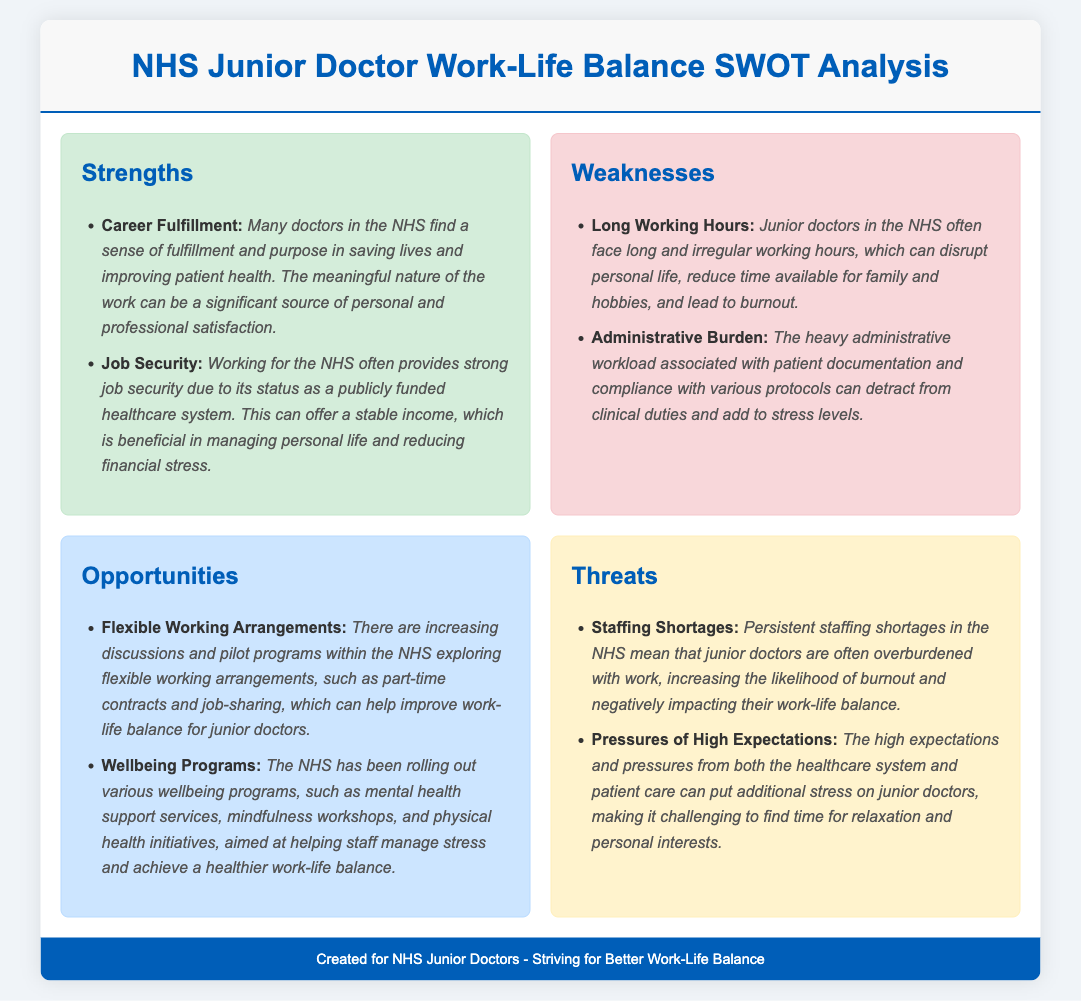What is one source of career fulfillment for NHS junior doctors? The document states that many doctors find fulfillment in saving lives and improving patient health.
Answer: Saving lives What are two listed weaknesses faced by junior doctors? The weaknesses mentioned in the document include long working hours and administrative burden.
Answer: Long working hours, Administrative burden What opportunity is mentioned regarding work arrangements? The document discusses flexible working arrangements, including part-time contracts and job-sharing.
Answer: Flexible working arrangements What program is the NHS rolling out to help staff? The document mentions wellbeing programs aimed at helping staff manage stress.
Answer: Wellbeing programs What is a threat due to staffing in the NHS? The document states that persistent staffing shortages lead to overburdened junior doctors.
Answer: Staffing shortages How do high expectations affect junior doctors? The document explains that high expectations increase stress, making relaxation and personal time challenging.
Answer: Increase stress What colors are used for strengths in the SWOT analysis? The document describes strengths highlighted in green shades.
Answer: Green shades What aspect of work-life balance is addressed by NHS programs? The document mentions mental health support services as part of the initiatives to improve work-life balance.
Answer: Mental health support services 